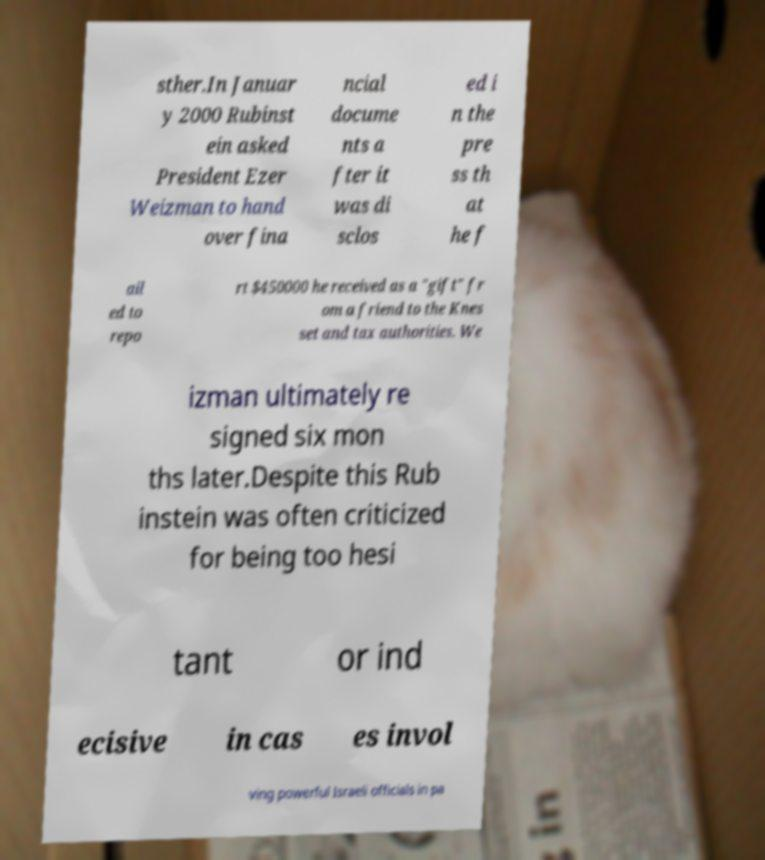What messages or text are displayed in this image? I need them in a readable, typed format. sther.In Januar y 2000 Rubinst ein asked President Ezer Weizman to hand over fina ncial docume nts a fter it was di sclos ed i n the pre ss th at he f ail ed to repo rt $450000 he received as a "gift" fr om a friend to the Knes set and tax authorities. We izman ultimately re signed six mon ths later.Despite this Rub instein was often criticized for being too hesi tant or ind ecisive in cas es invol ving powerful Israeli officials in pa 